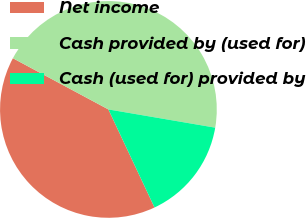Convert chart. <chart><loc_0><loc_0><loc_500><loc_500><pie_chart><fcel>Net income<fcel>Cash provided by (used for)<fcel>Cash (used for) provided by<nl><fcel>39.83%<fcel>44.86%<fcel>15.31%<nl></chart> 